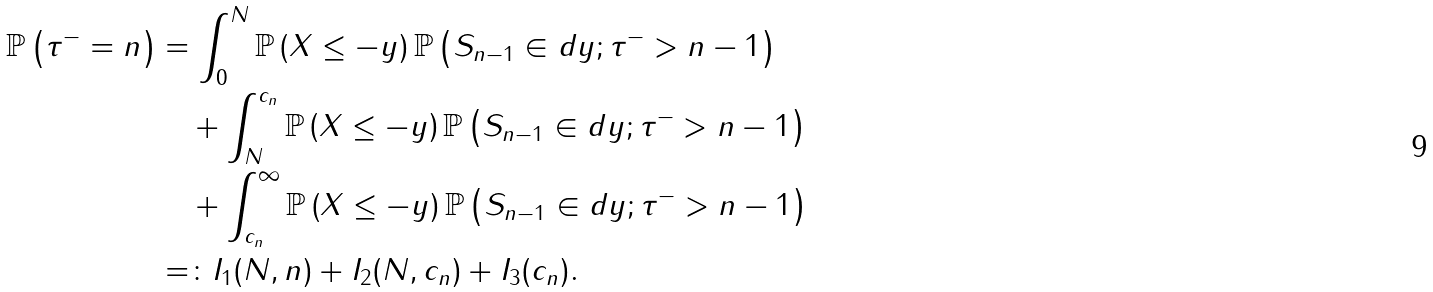<formula> <loc_0><loc_0><loc_500><loc_500>\mathbb { P } \left ( \tau ^ { - } = n \right ) & = \int _ { 0 } ^ { N } \mathbb { P } \left ( X \leq - y \right ) \mathbb { P } \left ( S _ { n - 1 } \in d y ; \tau ^ { - } > n - 1 \right ) \\ & \quad + \int _ { N } ^ { c _ { n } } \mathbb { P } \left ( X \leq - y \right ) \mathbb { P } \left ( S _ { n - 1 } \in d y ; \tau ^ { - } > n - 1 \right ) \\ & \quad + \int _ { c _ { n } } ^ { \infty } \mathbb { P } \left ( X \leq - y \right ) \mathbb { P } \left ( S _ { n - 1 } \in d y ; \tau ^ { - } > n - 1 \right ) \\ & = \colon I _ { 1 } ( N , n ) + I _ { 2 } ( N , c _ { n } ) + I _ { 3 } ( c _ { n } ) .</formula> 